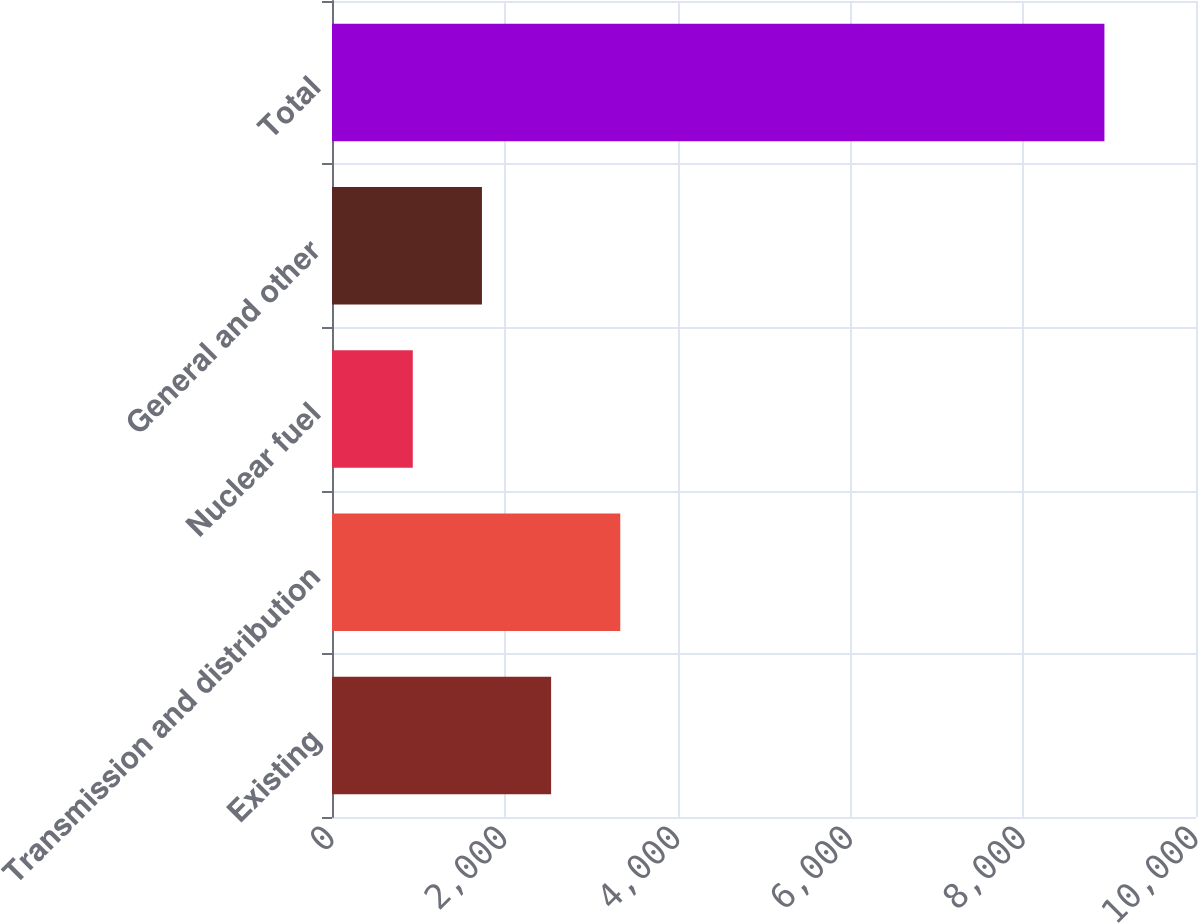Convert chart to OTSL. <chart><loc_0><loc_0><loc_500><loc_500><bar_chart><fcel>Existing<fcel>Transmission and distribution<fcel>Nuclear fuel<fcel>General and other<fcel>Total<nl><fcel>2536<fcel>3336.5<fcel>935<fcel>1735.5<fcel>8940<nl></chart> 